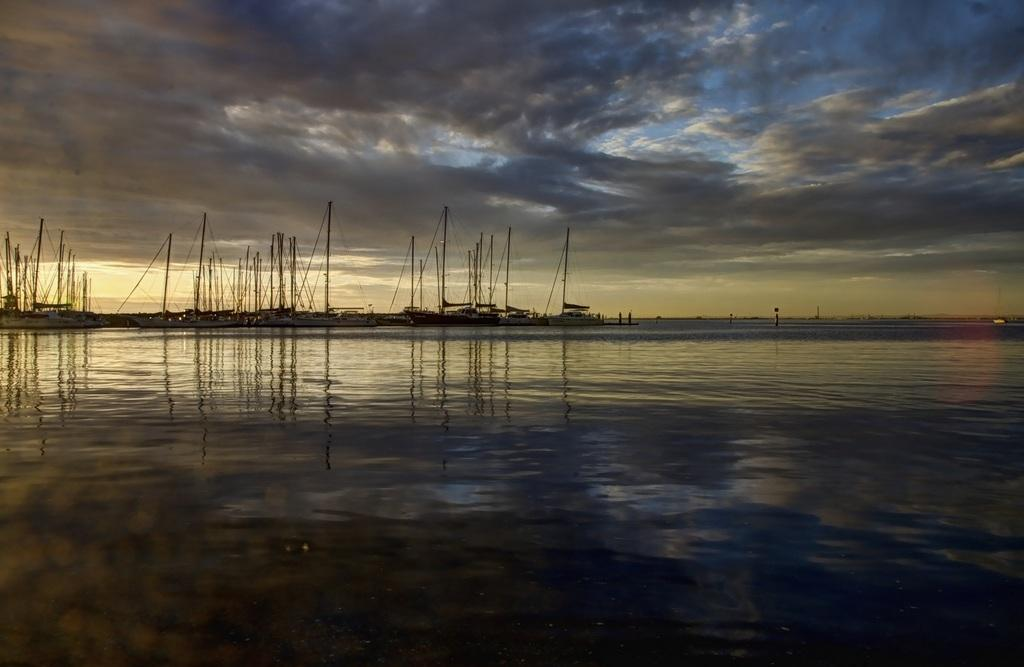What is at the bottom of the image? There is water at the bottom of the image. What can be seen in the water in the background? There are boats in the water in the background. What features do the boats have? The boats have poles and ropes. What is visible at the top of the image? The sky is visible at the top of the image. What can be observed in the sky? The sky contains clouds. Where is the street located in the image? There is no street present in the image; it features water, boats, and sky. What type of corn can be seen growing near the boats? There is no corn present in the image; it only contains water, boats, and sky. 